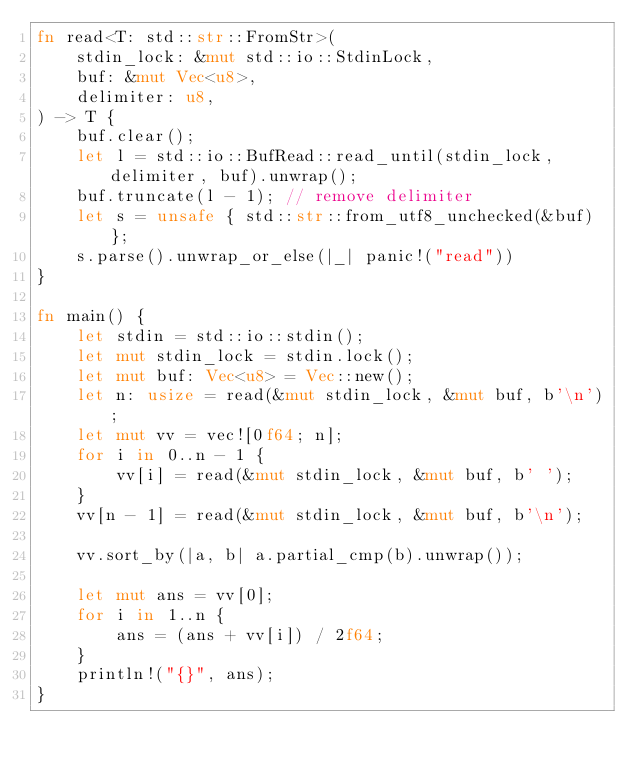<code> <loc_0><loc_0><loc_500><loc_500><_Rust_>fn read<T: std::str::FromStr>(
    stdin_lock: &mut std::io::StdinLock,
    buf: &mut Vec<u8>,
    delimiter: u8,
) -> T {
    buf.clear();
    let l = std::io::BufRead::read_until(stdin_lock, delimiter, buf).unwrap();
    buf.truncate(l - 1); // remove delimiter
    let s = unsafe { std::str::from_utf8_unchecked(&buf) };
    s.parse().unwrap_or_else(|_| panic!("read"))
}

fn main() {
    let stdin = std::io::stdin();
    let mut stdin_lock = stdin.lock();
    let mut buf: Vec<u8> = Vec::new();
    let n: usize = read(&mut stdin_lock, &mut buf, b'\n');
    let mut vv = vec![0f64; n];
    for i in 0..n - 1 {
        vv[i] = read(&mut stdin_lock, &mut buf, b' ');
    }
    vv[n - 1] = read(&mut stdin_lock, &mut buf, b'\n');

    vv.sort_by(|a, b| a.partial_cmp(b).unwrap());

    let mut ans = vv[0];
    for i in 1..n {
        ans = (ans + vv[i]) / 2f64;
    }
    println!("{}", ans);
}
</code> 